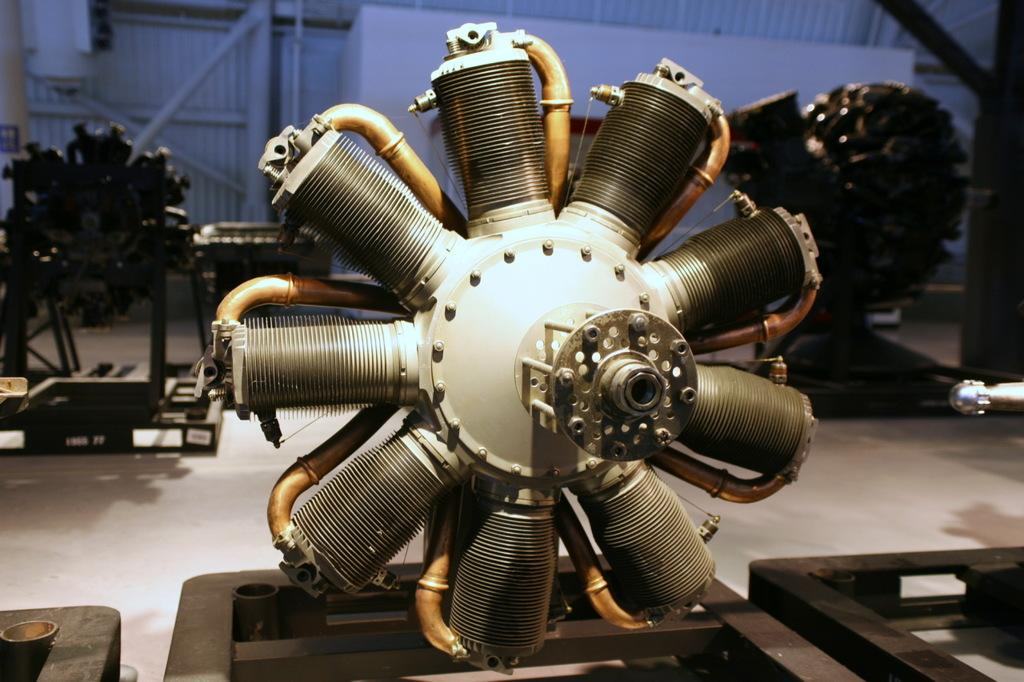What objects are on stands in the image? There are engines on stands in the image. Where are the stands placed? The stands are placed on the floor. What type of material are the poles made of? The poles visible in the image are made of metal. What type of structure can be seen in the image? There is a shed in the image. How many people are getting a haircut in the image? There is no indication of a haircut or any people in the image. What color are the eyes of the person in the image? There are no people or eyes visible in the image. 